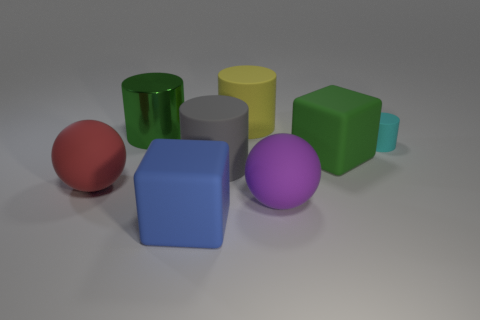What number of things are either small yellow metallic cubes or matte cylinders?
Your response must be concise. 3. There is a large green thing that is on the right side of the blue matte object; is its shape the same as the blue rubber thing?
Your answer should be compact. Yes. The large block right of the large rubber sphere right of the big yellow thing is what color?
Keep it short and to the point. Green. Is the number of big green matte cubes less than the number of matte blocks?
Make the answer very short. Yes. Is there a purple object that has the same material as the big blue cube?
Give a very brief answer. Yes. Do the big blue thing and the big purple thing on the right side of the large gray cylinder have the same shape?
Ensure brevity in your answer.  No. Are there any small cyan rubber cylinders behind the big gray object?
Keep it short and to the point. Yes. What number of other green things are the same shape as the big green metallic object?
Provide a succinct answer. 0. Do the large gray cylinder and the block to the left of the gray cylinder have the same material?
Your answer should be compact. Yes. How many big blue rubber blocks are there?
Offer a very short reply. 1. 